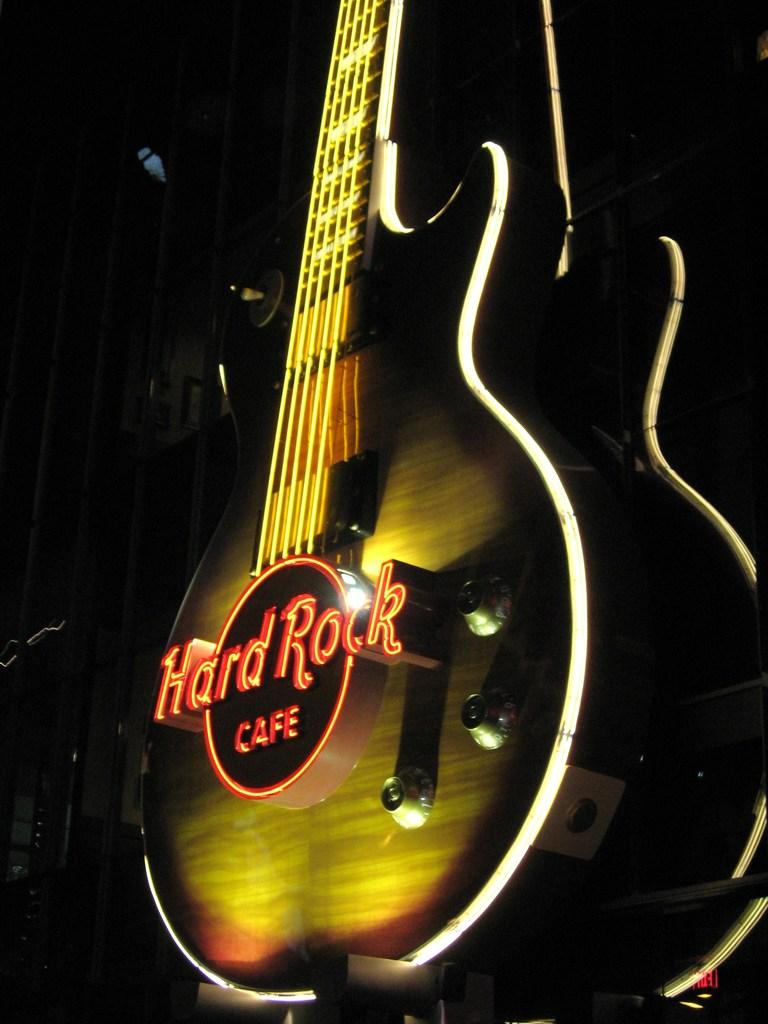What musical instrument can be seen in the image? There is a guitar in the image. What might someone be doing with the guitar in the image? It is not clear what the person is doing with the guitar, but they might be playing it, tuning it, or simply holding it. Can you describe the guitar in the image? The guitar appears to be an acoustic guitar with a wooden body and six strings. What type of smell can be detected from the guitar in the image? There is no smell associated with the guitar in the image, as it is a visual representation and not a physical object. 